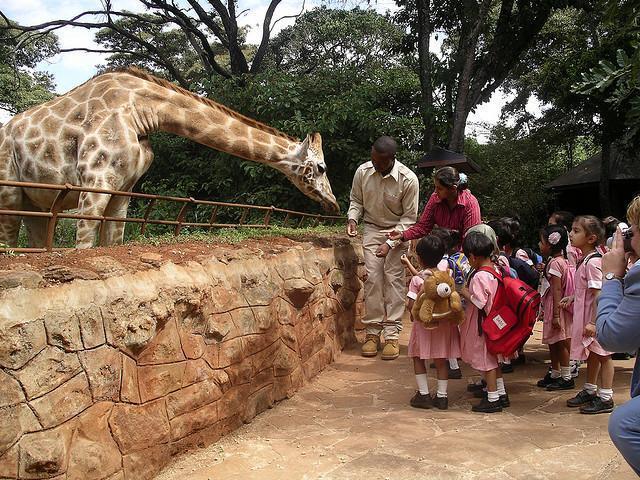How many backpacks can you see?
Give a very brief answer. 2. How many people are there?
Give a very brief answer. 7. 